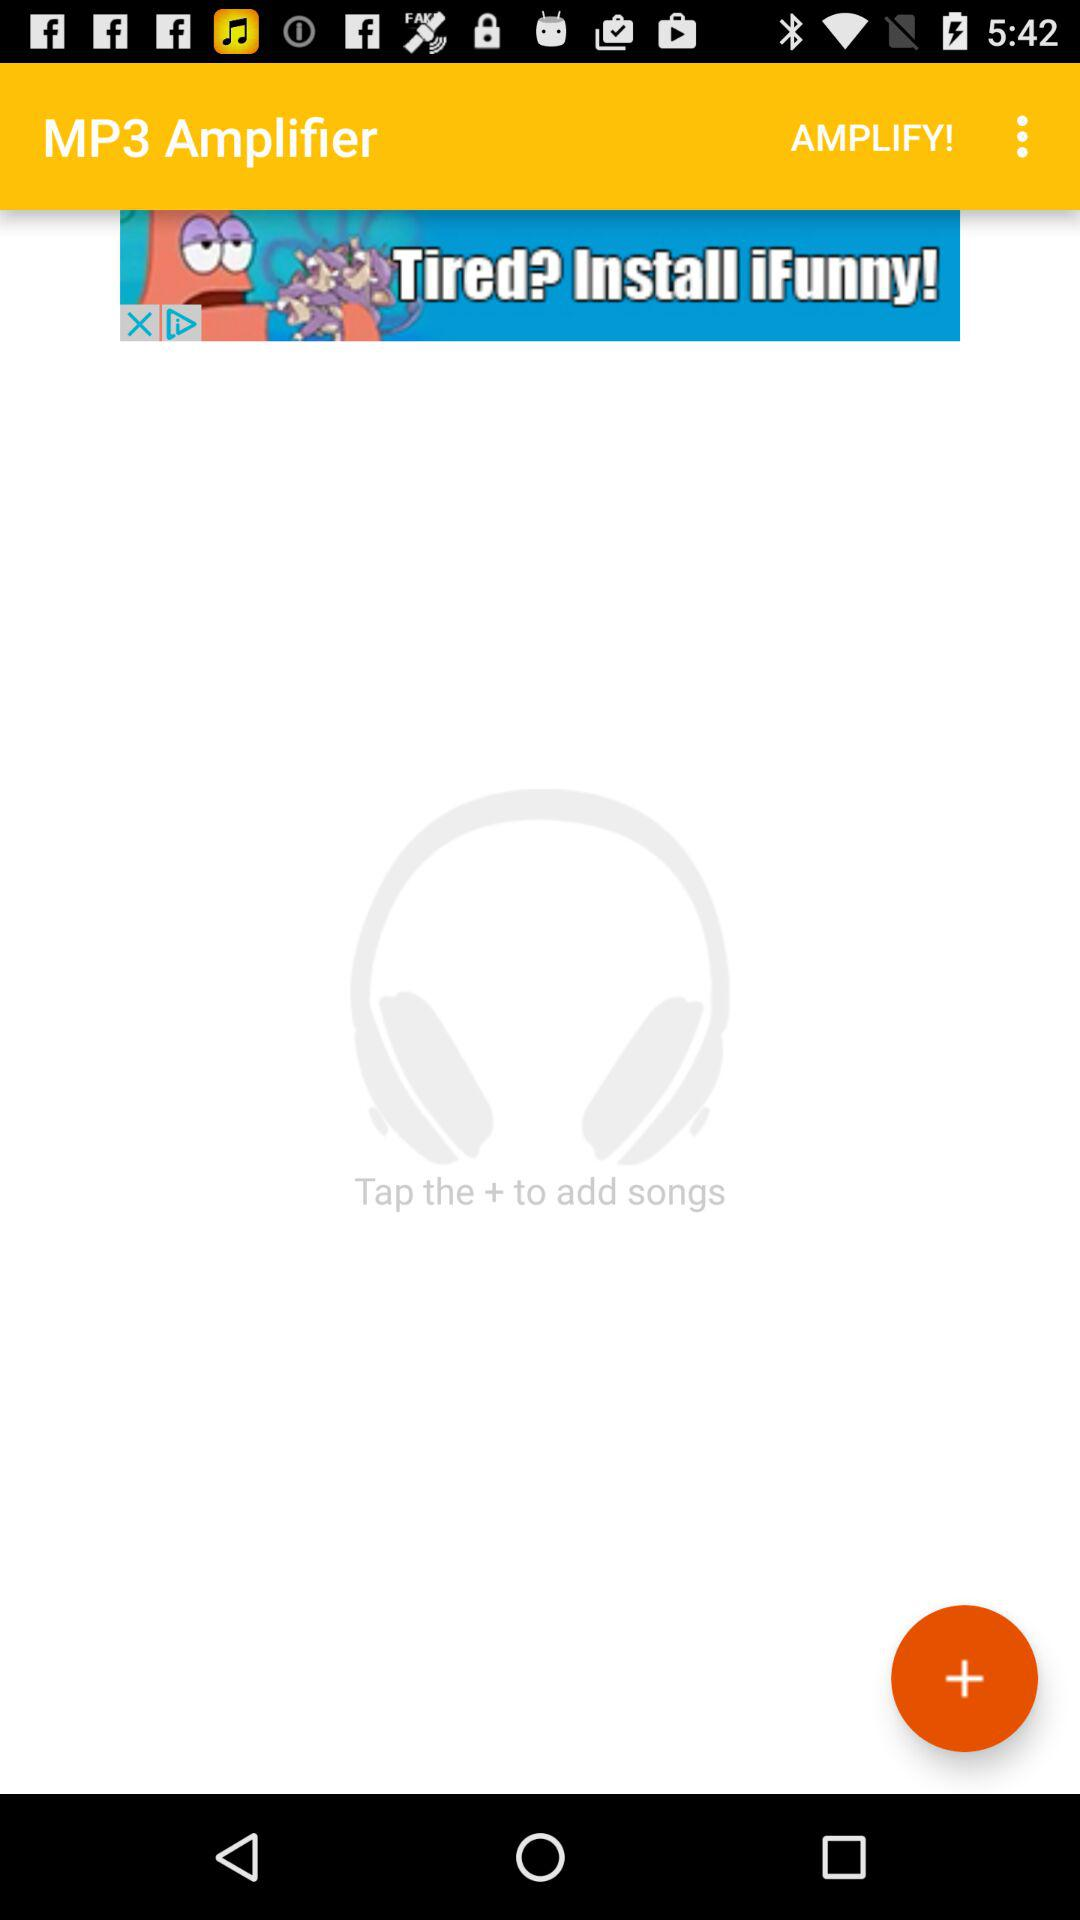How many songs can be amplified at once?
When the provided information is insufficient, respond with <no answer>. <no answer> 